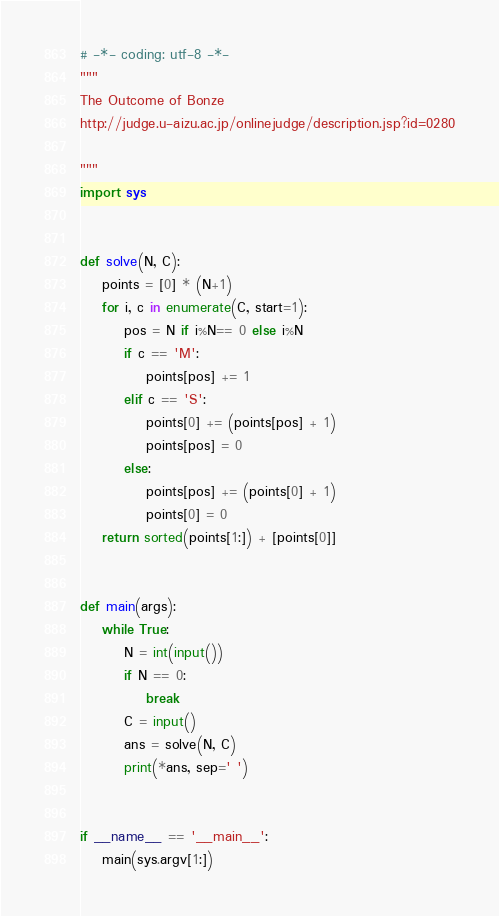<code> <loc_0><loc_0><loc_500><loc_500><_Python_># -*- coding: utf-8 -*-
"""
The Outcome of Bonze
http://judge.u-aizu.ac.jp/onlinejudge/description.jsp?id=0280

"""
import sys


def solve(N, C):
    points = [0] * (N+1)
    for i, c in enumerate(C, start=1):
        pos = N if i%N== 0 else i%N
        if c == 'M':
            points[pos] += 1
        elif c == 'S':
            points[0] += (points[pos] + 1)
            points[pos] = 0
        else:
            points[pos] += (points[0] + 1)
            points[0] = 0
    return sorted(points[1:]) + [points[0]]


def main(args):
    while True:
        N = int(input())
        if N == 0:
            break
        C = input()
        ans = solve(N, C)
        print(*ans, sep=' ')


if __name__ == '__main__':
    main(sys.argv[1:])

</code> 